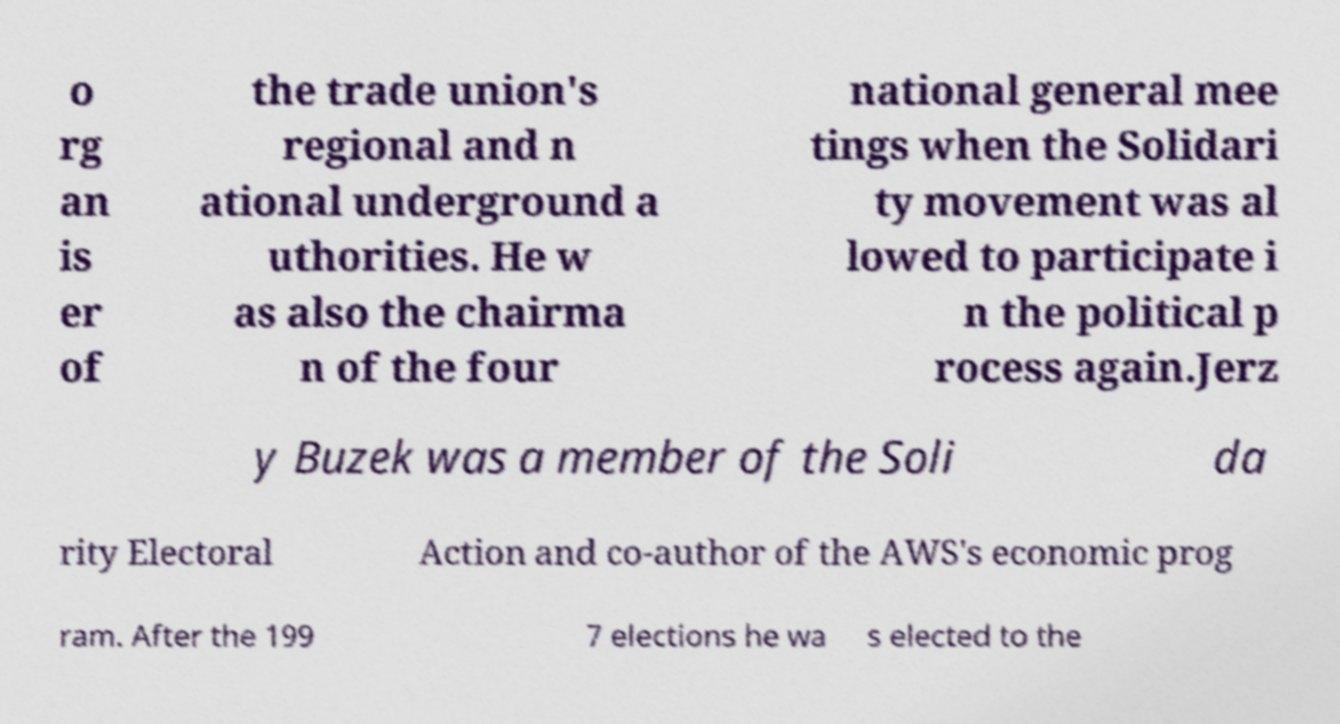There's text embedded in this image that I need extracted. Can you transcribe it verbatim? o rg an is er of the trade union's regional and n ational underground a uthorities. He w as also the chairma n of the four national general mee tings when the Solidari ty movement was al lowed to participate i n the political p rocess again.Jerz y Buzek was a member of the Soli da rity Electoral Action and co-author of the AWS's economic prog ram. After the 199 7 elections he wa s elected to the 